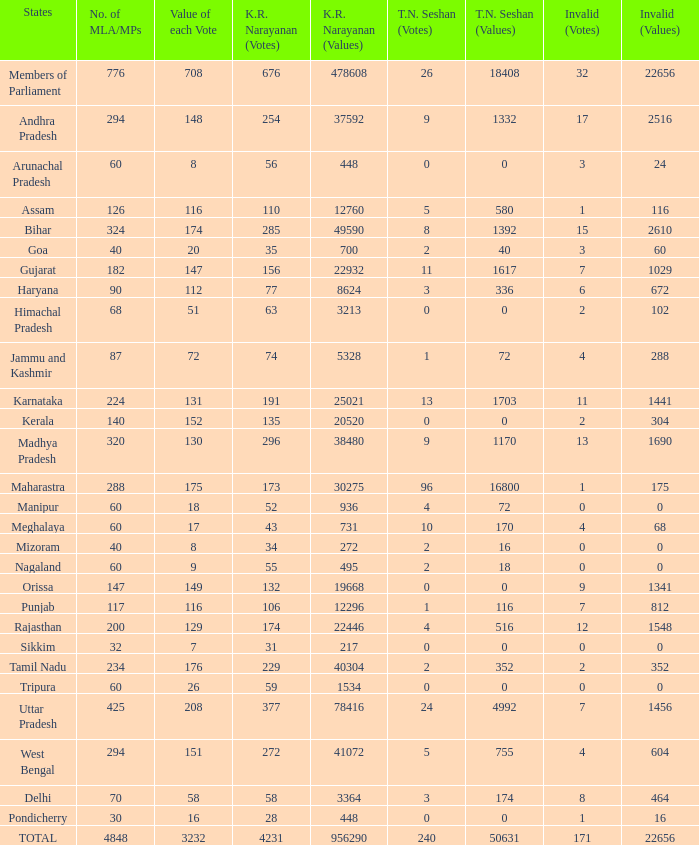Would you be able to parse every entry in this table? {'header': ['States', 'No. of MLA/MPs', 'Value of each Vote', 'K.R. Narayanan (Votes)', 'K.R. Narayanan (Values)', 'T.N. Seshan (Votes)', 'T.N. Seshan (Values)', 'Invalid (Votes)', 'Invalid (Values)'], 'rows': [['Members of Parliament', '776', '708', '676', '478608', '26', '18408', '32', '22656'], ['Andhra Pradesh', '294', '148', '254', '37592', '9', '1332', '17', '2516'], ['Arunachal Pradesh', '60', '8', '56', '448', '0', '0', '3', '24'], ['Assam', '126', '116', '110', '12760', '5', '580', '1', '116'], ['Bihar', '324', '174', '285', '49590', '8', '1392', '15', '2610'], ['Goa', '40', '20', '35', '700', '2', '40', '3', '60'], ['Gujarat', '182', '147', '156', '22932', '11', '1617', '7', '1029'], ['Haryana', '90', '112', '77', '8624', '3', '336', '6', '672'], ['Himachal Pradesh', '68', '51', '63', '3213', '0', '0', '2', '102'], ['Jammu and Kashmir', '87', '72', '74', '5328', '1', '72', '4', '288'], ['Karnataka', '224', '131', '191', '25021', '13', '1703', '11', '1441'], ['Kerala', '140', '152', '135', '20520', '0', '0', '2', '304'], ['Madhya Pradesh', '320', '130', '296', '38480', '9', '1170', '13', '1690'], ['Maharastra', '288', '175', '173', '30275', '96', '16800', '1', '175'], ['Manipur', '60', '18', '52', '936', '4', '72', '0', '0'], ['Meghalaya', '60', '17', '43', '731', '10', '170', '4', '68'], ['Mizoram', '40', '8', '34', '272', '2', '16', '0', '0'], ['Nagaland', '60', '9', '55', '495', '2', '18', '0', '0'], ['Orissa', '147', '149', '132', '19668', '0', '0', '9', '1341'], ['Punjab', '117', '116', '106', '12296', '1', '116', '7', '812'], ['Rajasthan', '200', '129', '174', '22446', '4', '516', '12', '1548'], ['Sikkim', '32', '7', '31', '217', '0', '0', '0', '0'], ['Tamil Nadu', '234', '176', '229', '40304', '2', '352', '2', '352'], ['Tripura', '60', '26', '59', '1534', '0', '0', '0', '0'], ['Uttar Pradesh', '425', '208', '377', '78416', '24', '4992', '7', '1456'], ['West Bengal', '294', '151', '272', '41072', '5', '755', '4', '604'], ['Delhi', '70', '58', '58', '3364', '3', '174', '8', '464'], ['Pondicherry', '30', '16', '28', '448', '0', '0', '1', '16'], ['TOTAL', '4848', '3232', '4231', '956290', '240', '50631', '171', '22656']]} Determine the greatest kr amount per vote when considering 208 votes. 377.0. 